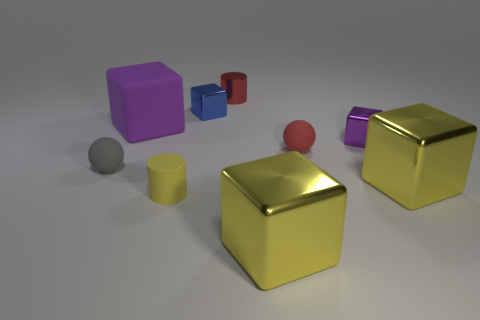Add 1 small gray things. How many objects exist? 10 Subtract all blue metallic blocks. How many blocks are left? 4 Subtract all purple cylinders. Subtract all blue blocks. How many cylinders are left? 2 Subtract all green cubes. How many red balls are left? 1 Subtract all purple things. Subtract all cylinders. How many objects are left? 5 Add 5 red spheres. How many red spheres are left? 6 Add 6 small yellow things. How many small yellow things exist? 7 Subtract all red cylinders. How many cylinders are left? 1 Subtract 0 cyan spheres. How many objects are left? 9 Subtract all cylinders. How many objects are left? 7 